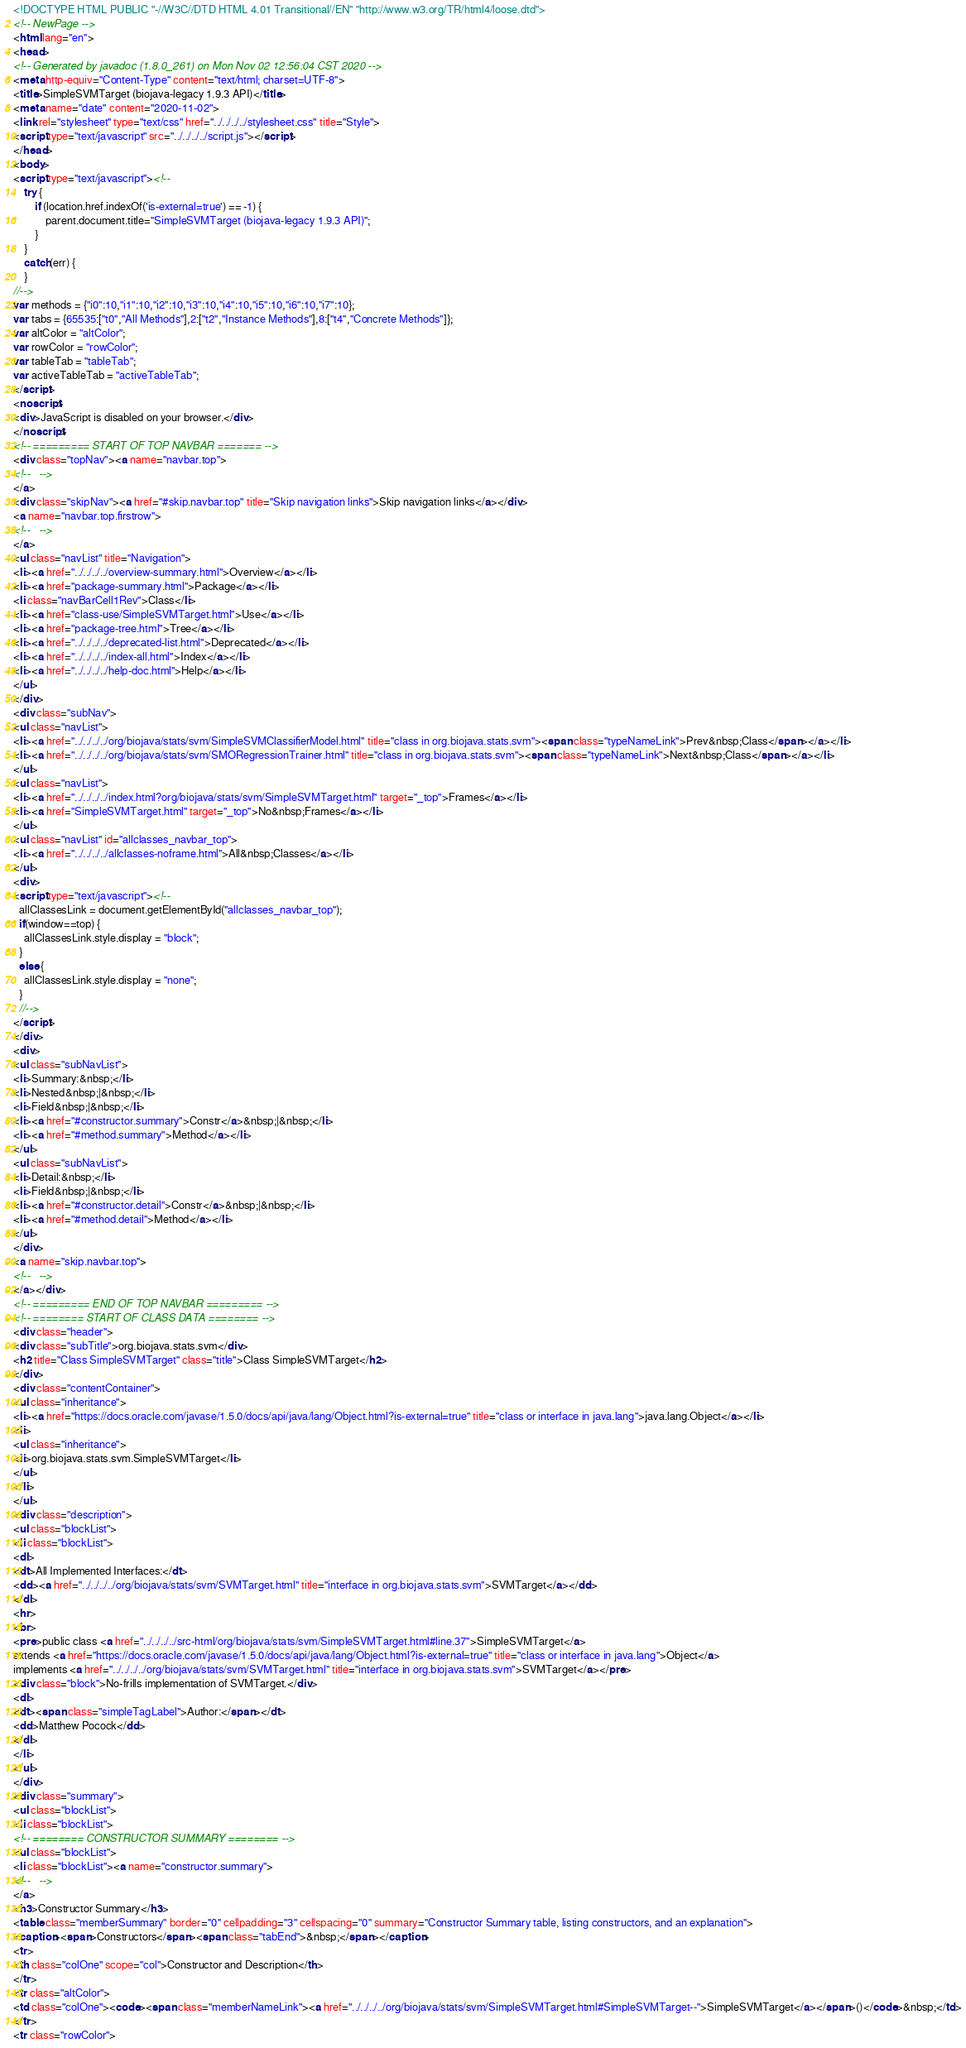Convert code to text. <code><loc_0><loc_0><loc_500><loc_500><_HTML_><!DOCTYPE HTML PUBLIC "-//W3C//DTD HTML 4.01 Transitional//EN" "http://www.w3.org/TR/html4/loose.dtd">
<!-- NewPage -->
<html lang="en">
<head>
<!-- Generated by javadoc (1.8.0_261) on Mon Nov 02 12:56:04 CST 2020 -->
<meta http-equiv="Content-Type" content="text/html; charset=UTF-8">
<title>SimpleSVMTarget (biojava-legacy 1.9.3 API)</title>
<meta name="date" content="2020-11-02">
<link rel="stylesheet" type="text/css" href="../../../../stylesheet.css" title="Style">
<script type="text/javascript" src="../../../../script.js"></script>
</head>
<body>
<script type="text/javascript"><!--
    try {
        if (location.href.indexOf('is-external=true') == -1) {
            parent.document.title="SimpleSVMTarget (biojava-legacy 1.9.3 API)";
        }
    }
    catch(err) {
    }
//-->
var methods = {"i0":10,"i1":10,"i2":10,"i3":10,"i4":10,"i5":10,"i6":10,"i7":10};
var tabs = {65535:["t0","All Methods"],2:["t2","Instance Methods"],8:["t4","Concrete Methods"]};
var altColor = "altColor";
var rowColor = "rowColor";
var tableTab = "tableTab";
var activeTableTab = "activeTableTab";
</script>
<noscript>
<div>JavaScript is disabled on your browser.</div>
</noscript>
<!-- ========= START OF TOP NAVBAR ======= -->
<div class="topNav"><a name="navbar.top">
<!--   -->
</a>
<div class="skipNav"><a href="#skip.navbar.top" title="Skip navigation links">Skip navigation links</a></div>
<a name="navbar.top.firstrow">
<!--   -->
</a>
<ul class="navList" title="Navigation">
<li><a href="../../../../overview-summary.html">Overview</a></li>
<li><a href="package-summary.html">Package</a></li>
<li class="navBarCell1Rev">Class</li>
<li><a href="class-use/SimpleSVMTarget.html">Use</a></li>
<li><a href="package-tree.html">Tree</a></li>
<li><a href="../../../../deprecated-list.html">Deprecated</a></li>
<li><a href="../../../../index-all.html">Index</a></li>
<li><a href="../../../../help-doc.html">Help</a></li>
</ul>
</div>
<div class="subNav">
<ul class="navList">
<li><a href="../../../../org/biojava/stats/svm/SimpleSVMClassifierModel.html" title="class in org.biojava.stats.svm"><span class="typeNameLink">Prev&nbsp;Class</span></a></li>
<li><a href="../../../../org/biojava/stats/svm/SMORegressionTrainer.html" title="class in org.biojava.stats.svm"><span class="typeNameLink">Next&nbsp;Class</span></a></li>
</ul>
<ul class="navList">
<li><a href="../../../../index.html?org/biojava/stats/svm/SimpleSVMTarget.html" target="_top">Frames</a></li>
<li><a href="SimpleSVMTarget.html" target="_top">No&nbsp;Frames</a></li>
</ul>
<ul class="navList" id="allclasses_navbar_top">
<li><a href="../../../../allclasses-noframe.html">All&nbsp;Classes</a></li>
</ul>
<div>
<script type="text/javascript"><!--
  allClassesLink = document.getElementById("allclasses_navbar_top");
  if(window==top) {
    allClassesLink.style.display = "block";
  }
  else {
    allClassesLink.style.display = "none";
  }
  //-->
</script>
</div>
<div>
<ul class="subNavList">
<li>Summary:&nbsp;</li>
<li>Nested&nbsp;|&nbsp;</li>
<li>Field&nbsp;|&nbsp;</li>
<li><a href="#constructor.summary">Constr</a>&nbsp;|&nbsp;</li>
<li><a href="#method.summary">Method</a></li>
</ul>
<ul class="subNavList">
<li>Detail:&nbsp;</li>
<li>Field&nbsp;|&nbsp;</li>
<li><a href="#constructor.detail">Constr</a>&nbsp;|&nbsp;</li>
<li><a href="#method.detail">Method</a></li>
</ul>
</div>
<a name="skip.navbar.top">
<!--   -->
</a></div>
<!-- ========= END OF TOP NAVBAR ========= -->
<!-- ======== START OF CLASS DATA ======== -->
<div class="header">
<div class="subTitle">org.biojava.stats.svm</div>
<h2 title="Class SimpleSVMTarget" class="title">Class SimpleSVMTarget</h2>
</div>
<div class="contentContainer">
<ul class="inheritance">
<li><a href="https://docs.oracle.com/javase/1.5.0/docs/api/java/lang/Object.html?is-external=true" title="class or interface in java.lang">java.lang.Object</a></li>
<li>
<ul class="inheritance">
<li>org.biojava.stats.svm.SimpleSVMTarget</li>
</ul>
</li>
</ul>
<div class="description">
<ul class="blockList">
<li class="blockList">
<dl>
<dt>All Implemented Interfaces:</dt>
<dd><a href="../../../../org/biojava/stats/svm/SVMTarget.html" title="interface in org.biojava.stats.svm">SVMTarget</a></dd>
</dl>
<hr>
<br>
<pre>public class <a href="../../../../src-html/org/biojava/stats/svm/SimpleSVMTarget.html#line.37">SimpleSVMTarget</a>
extends <a href="https://docs.oracle.com/javase/1.5.0/docs/api/java/lang/Object.html?is-external=true" title="class or interface in java.lang">Object</a>
implements <a href="../../../../org/biojava/stats/svm/SVMTarget.html" title="interface in org.biojava.stats.svm">SVMTarget</a></pre>
<div class="block">No-frills implementation of SVMTarget.</div>
<dl>
<dt><span class="simpleTagLabel">Author:</span></dt>
<dd>Matthew Pocock</dd>
</dl>
</li>
</ul>
</div>
<div class="summary">
<ul class="blockList">
<li class="blockList">
<!-- ======== CONSTRUCTOR SUMMARY ======== -->
<ul class="blockList">
<li class="blockList"><a name="constructor.summary">
<!--   -->
</a>
<h3>Constructor Summary</h3>
<table class="memberSummary" border="0" cellpadding="3" cellspacing="0" summary="Constructor Summary table, listing constructors, and an explanation">
<caption><span>Constructors</span><span class="tabEnd">&nbsp;</span></caption>
<tr>
<th class="colOne" scope="col">Constructor and Description</th>
</tr>
<tr class="altColor">
<td class="colOne"><code><span class="memberNameLink"><a href="../../../../org/biojava/stats/svm/SimpleSVMTarget.html#SimpleSVMTarget--">SimpleSVMTarget</a></span>()</code>&nbsp;</td>
</tr>
<tr class="rowColor"></code> 